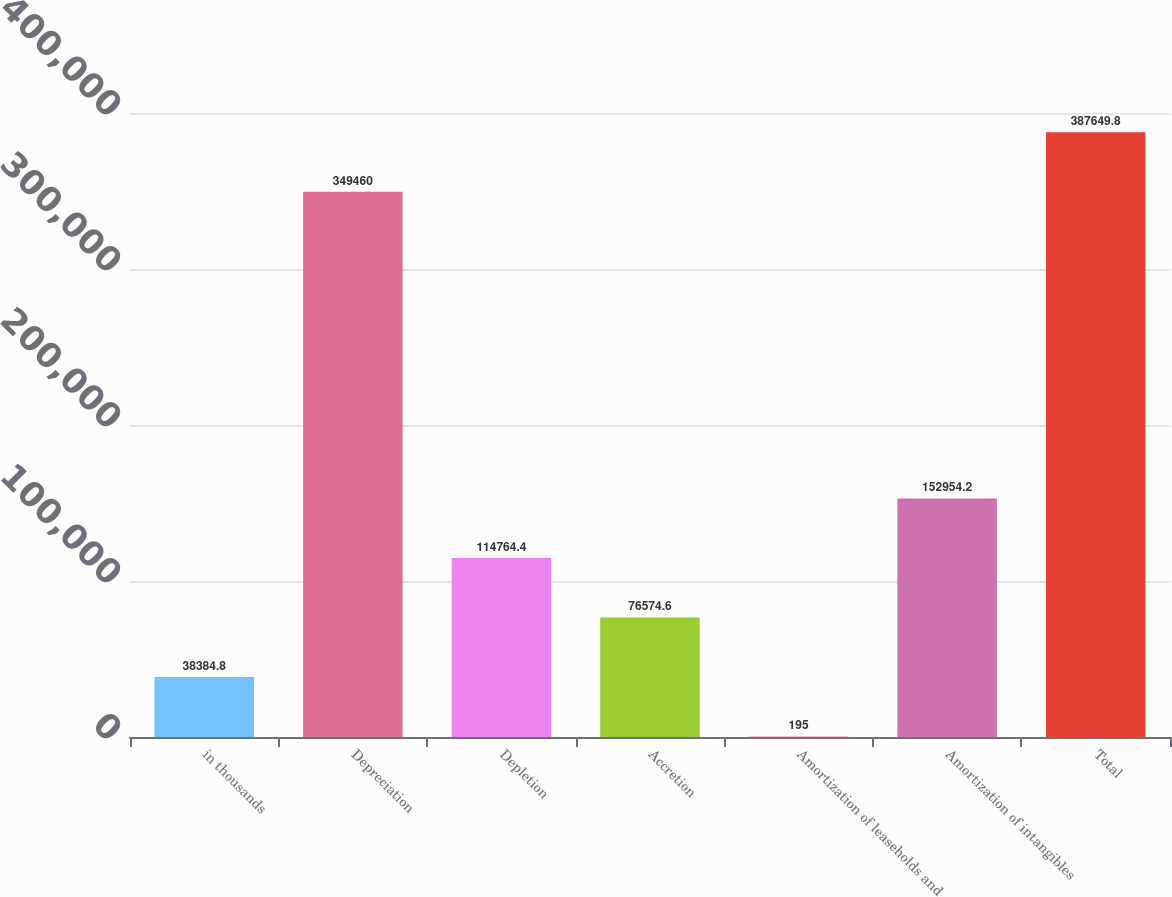Convert chart to OTSL. <chart><loc_0><loc_0><loc_500><loc_500><bar_chart><fcel>in thousands<fcel>Depreciation<fcel>Depletion<fcel>Accretion<fcel>Amortization of leaseholds and<fcel>Amortization of intangibles<fcel>Total<nl><fcel>38384.8<fcel>349460<fcel>114764<fcel>76574.6<fcel>195<fcel>152954<fcel>387650<nl></chart> 